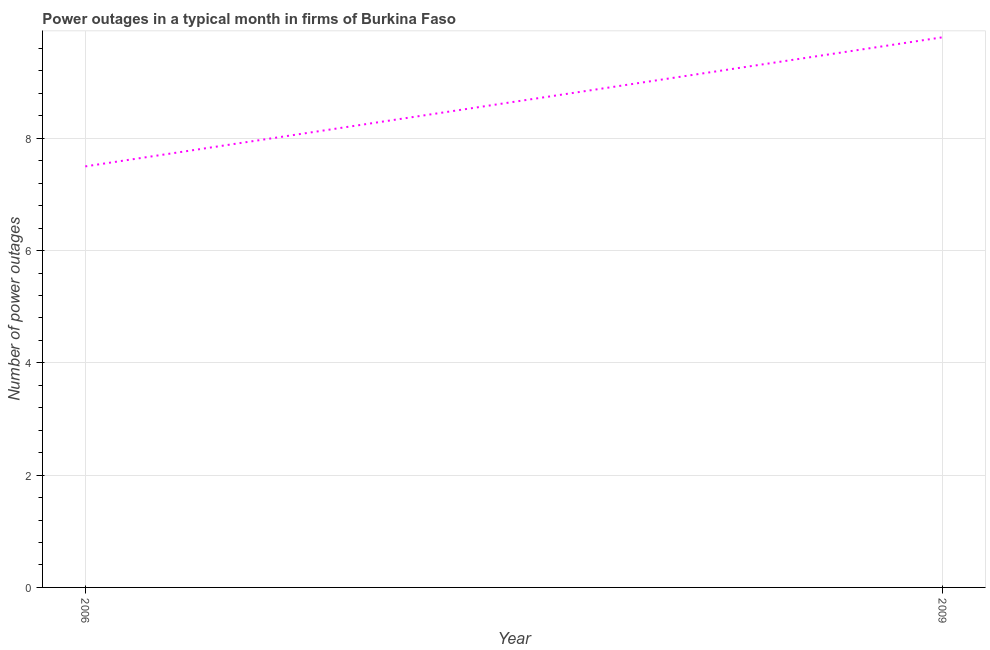What is the number of power outages in 2006?
Your answer should be compact. 7.5. Across all years, what is the maximum number of power outages?
Keep it short and to the point. 9.8. In which year was the number of power outages maximum?
Provide a succinct answer. 2009. What is the sum of the number of power outages?
Your response must be concise. 17.3. What is the difference between the number of power outages in 2006 and 2009?
Make the answer very short. -2.3. What is the average number of power outages per year?
Your response must be concise. 8.65. What is the median number of power outages?
Make the answer very short. 8.65. In how many years, is the number of power outages greater than 2.8 ?
Your response must be concise. 2. Do a majority of the years between 2009 and 2006 (inclusive) have number of power outages greater than 5.6 ?
Your answer should be compact. No. What is the ratio of the number of power outages in 2006 to that in 2009?
Your response must be concise. 0.77. What is the difference between two consecutive major ticks on the Y-axis?
Offer a very short reply. 2. Are the values on the major ticks of Y-axis written in scientific E-notation?
Offer a terse response. No. What is the title of the graph?
Give a very brief answer. Power outages in a typical month in firms of Burkina Faso. What is the label or title of the Y-axis?
Your answer should be very brief. Number of power outages. What is the Number of power outages in 2009?
Provide a succinct answer. 9.8. What is the difference between the Number of power outages in 2006 and 2009?
Provide a succinct answer. -2.3. What is the ratio of the Number of power outages in 2006 to that in 2009?
Make the answer very short. 0.77. 